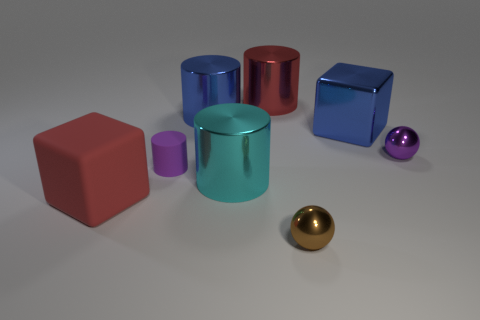What number of big cubes are both in front of the cyan object and to the right of the small purple cylinder?
Give a very brief answer. 0. There is a tiny brown shiny object; is its shape the same as the red object in front of the big blue metal cylinder?
Offer a very short reply. No. Are there more red matte blocks that are on the left side of the tiny rubber cylinder than small gray things?
Make the answer very short. Yes. Is the number of large blue things in front of the purple cylinder less than the number of tiny gray balls?
Provide a succinct answer. No. How many big blocks are the same color as the small rubber thing?
Keep it short and to the point. 0. What is the material of the object that is both in front of the cyan metallic cylinder and behind the tiny brown shiny sphere?
Provide a short and direct response. Rubber. There is a ball in front of the tiny purple ball; does it have the same color as the block that is behind the large red matte cube?
Offer a very short reply. No. How many purple things are either big things or large cylinders?
Offer a very short reply. 0. Are there fewer blue cylinders that are left of the tiny purple matte cylinder than balls behind the small brown ball?
Offer a very short reply. Yes. Are there any purple metallic things of the same size as the red cylinder?
Your answer should be very brief. No. 